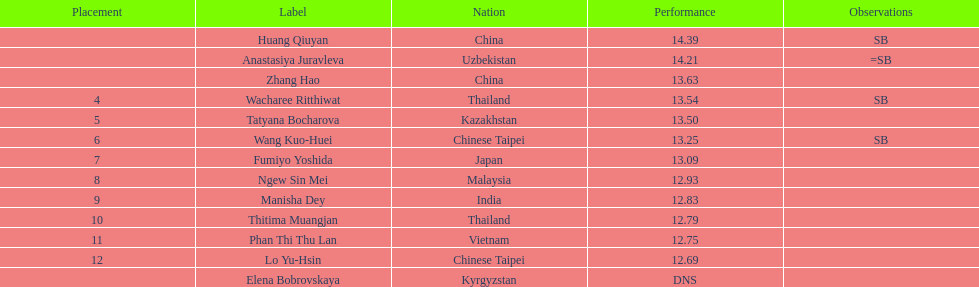Which country came in first? China. 